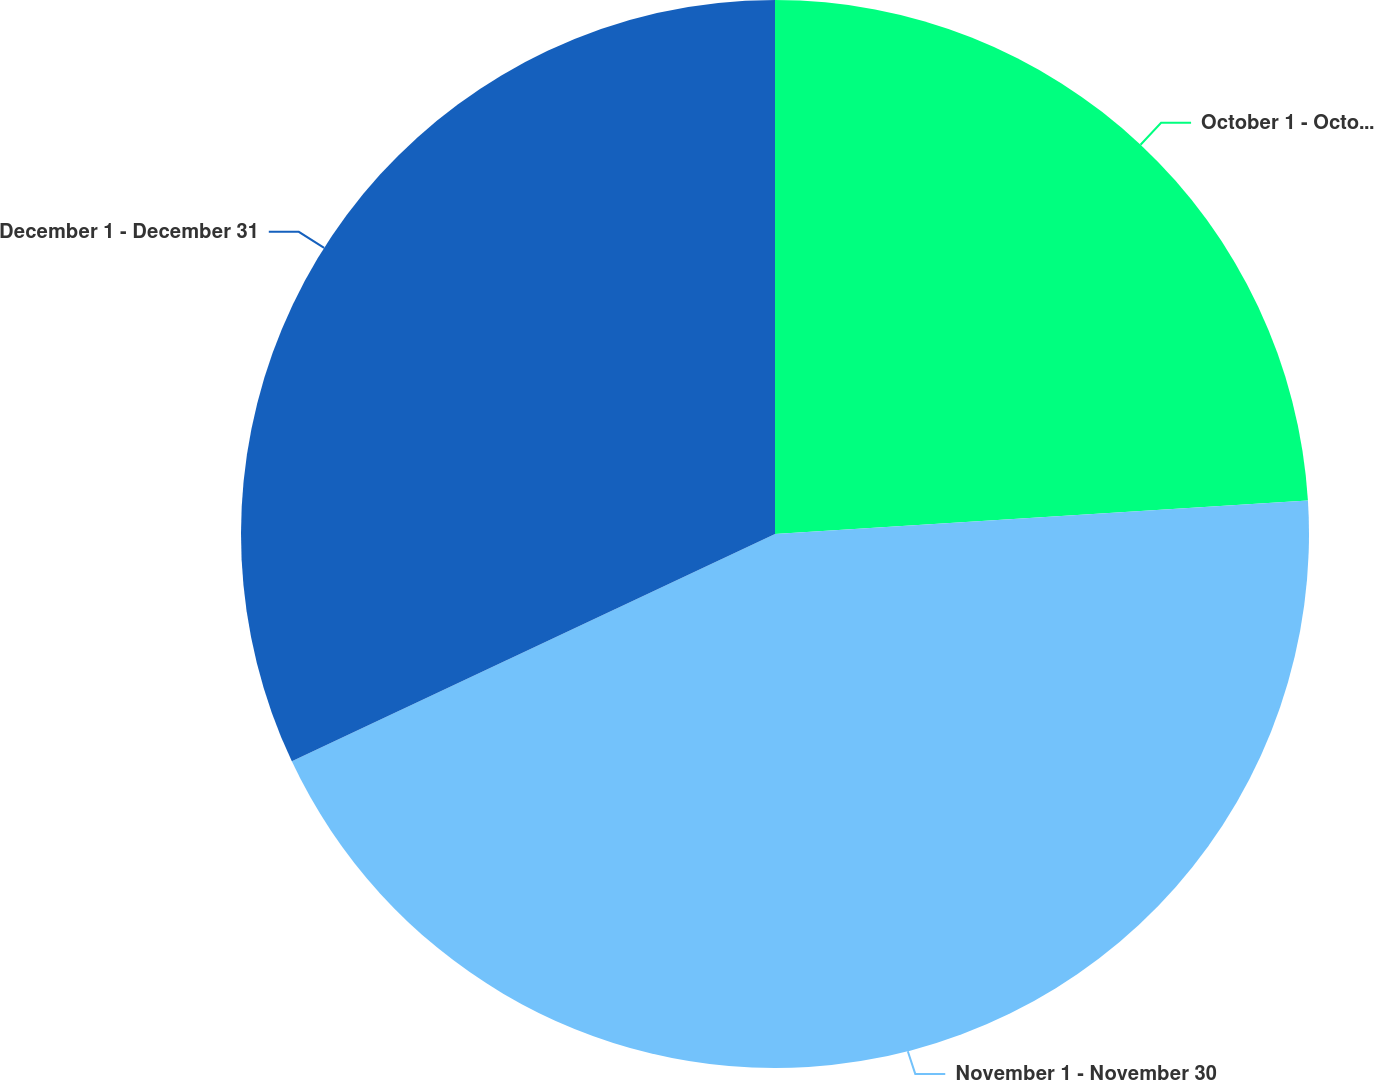Convert chart. <chart><loc_0><loc_0><loc_500><loc_500><pie_chart><fcel>October 1 - October 31<fcel>November 1 - November 30<fcel>December 1 - December 31<nl><fcel>24.0%<fcel>44.0%<fcel>32.0%<nl></chart> 